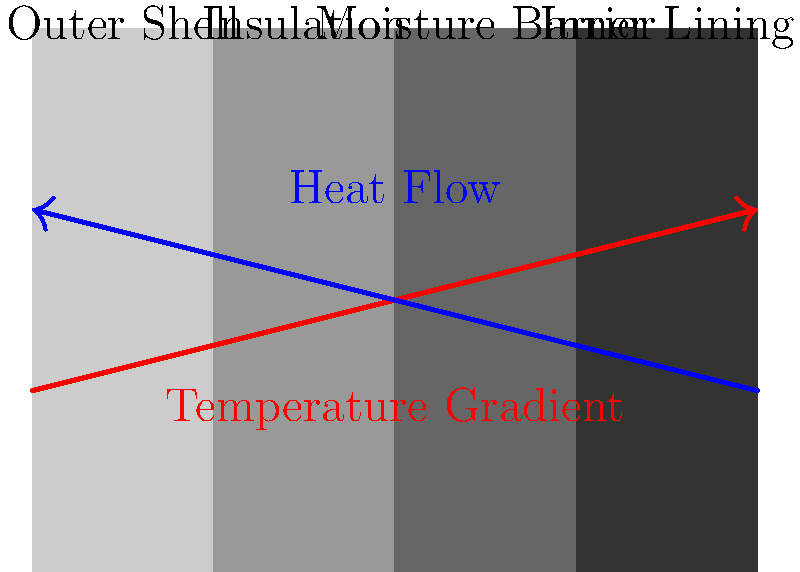In designing a stylish, mindfulness-inspired winter coat, you want to optimize heat transfer properties. Given a four-layer design with an outer shell, insulation, moisture barrier, and inner lining, which layer contributes most significantly to the overall thermal resistance (R-value) of the coat? To determine which layer contributes most significantly to the overall thermal resistance of the coat, we need to consider the heat transfer properties of each layer:

1. Outer Shell: Typically made of tightly woven fabric, it provides wind resistance but minimal insulation.

2. Insulation Layer: Usually made of materials like down, synthetic fibers, or wool, this layer traps air and provides the majority of the thermal resistance.

3. Moisture Barrier: A thin layer that prevents water from entering while allowing water vapor to escape. It has minimal thermal resistance.

4. Inner Lining: Usually a lightweight fabric for comfort, it provides minimal insulation.

The thermal resistance (R-value) of a material is proportional to its thickness and inversely proportional to its thermal conductivity:

$$ R = \frac{L}{k} $$

Where:
$R$ = Thermal resistance
$L$ = Thickness of the material
$k$ = Thermal conductivity

The insulation layer is typically the thickest layer and is made of materials with very low thermal conductivity. Therefore, it has the highest R-value among all layers.

The overall R-value of the coat is the sum of the R-values of individual layers:

$$ R_{total} = R_{outer} + R_{insulation} + R_{moisture} + R_{inner} $$

Due to its thickness and low thermal conductivity, the R-value of the insulation layer is significantly higher than the other layers, making it the most significant contributor to the overall thermal resistance of the coat.
Answer: Insulation layer 